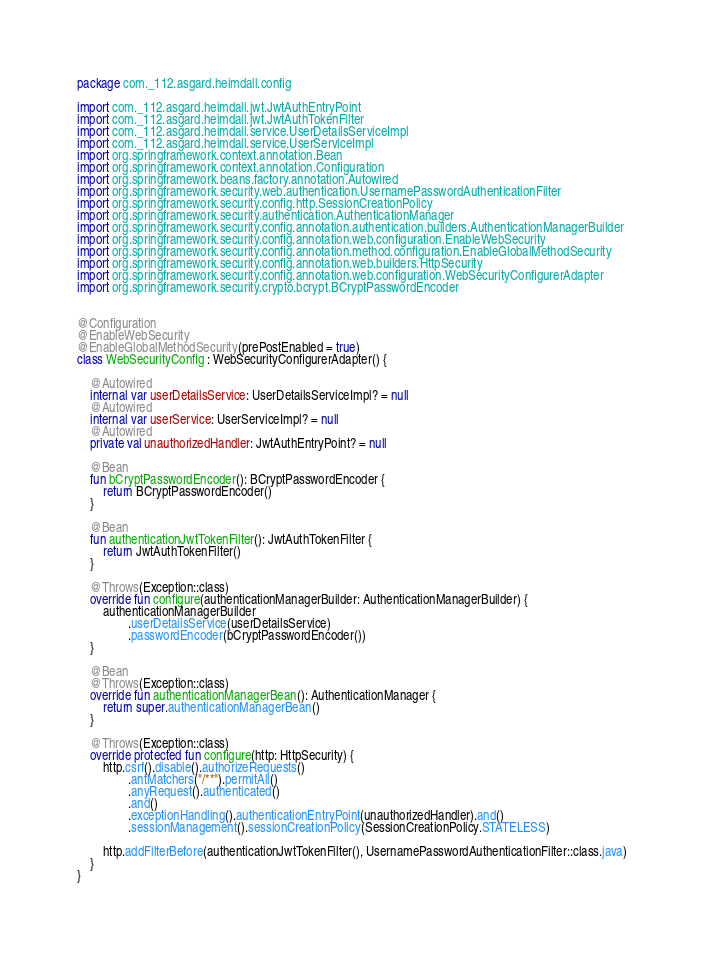<code> <loc_0><loc_0><loc_500><loc_500><_Kotlin_>package com._112.asgard.heimdall.config

import com._112.asgard.heimdall.jwt.JwtAuthEntryPoint
import com._112.asgard.heimdall.jwt.JwtAuthTokenFilter
import com._112.asgard.heimdall.service.UserDetailsServiceImpl
import com._112.asgard.heimdall.service.UserServiceImpl
import org.springframework.context.annotation.Bean
import org.springframework.context.annotation.Configuration
import org.springframework.beans.factory.annotation.Autowired
import org.springframework.security.web.authentication.UsernamePasswordAuthenticationFilter
import org.springframework.security.config.http.SessionCreationPolicy
import org.springframework.security.authentication.AuthenticationManager
import org.springframework.security.config.annotation.authentication.builders.AuthenticationManagerBuilder
import org.springframework.security.config.annotation.web.configuration.EnableWebSecurity
import org.springframework.security.config.annotation.method.configuration.EnableGlobalMethodSecurity
import org.springframework.security.config.annotation.web.builders.HttpSecurity
import org.springframework.security.config.annotation.web.configuration.WebSecurityConfigurerAdapter
import org.springframework.security.crypto.bcrypt.BCryptPasswordEncoder


@Configuration
@EnableWebSecurity
@EnableGlobalMethodSecurity(prePostEnabled = true)
class WebSecurityConfig : WebSecurityConfigurerAdapter() {

    @Autowired
    internal var userDetailsService: UserDetailsServiceImpl? = null
    @Autowired
    internal var userService: UserServiceImpl? = null
    @Autowired
    private val unauthorizedHandler: JwtAuthEntryPoint? = null

    @Bean
    fun bCryptPasswordEncoder(): BCryptPasswordEncoder {
        return BCryptPasswordEncoder()
    }

    @Bean
    fun authenticationJwtTokenFilter(): JwtAuthTokenFilter {
        return JwtAuthTokenFilter()
    }

    @Throws(Exception::class)
    override fun configure(authenticationManagerBuilder: AuthenticationManagerBuilder) {
        authenticationManagerBuilder
                .userDetailsService(userDetailsService)
                .passwordEncoder(bCryptPasswordEncoder())
    }

    @Bean
    @Throws(Exception::class)
    override fun authenticationManagerBean(): AuthenticationManager {
        return super.authenticationManagerBean()
    }

    @Throws(Exception::class)
    override protected fun configure(http: HttpSecurity) {
        http.csrf().disable().authorizeRequests()
                .antMatchers("/**").permitAll()
                .anyRequest().authenticated()
                .and()
                .exceptionHandling().authenticationEntryPoint(unauthorizedHandler).and()
                .sessionManagement().sessionCreationPolicy(SessionCreationPolicy.STATELESS)

        http.addFilterBefore(authenticationJwtTokenFilter(), UsernamePasswordAuthenticationFilter::class.java)
    }
}</code> 